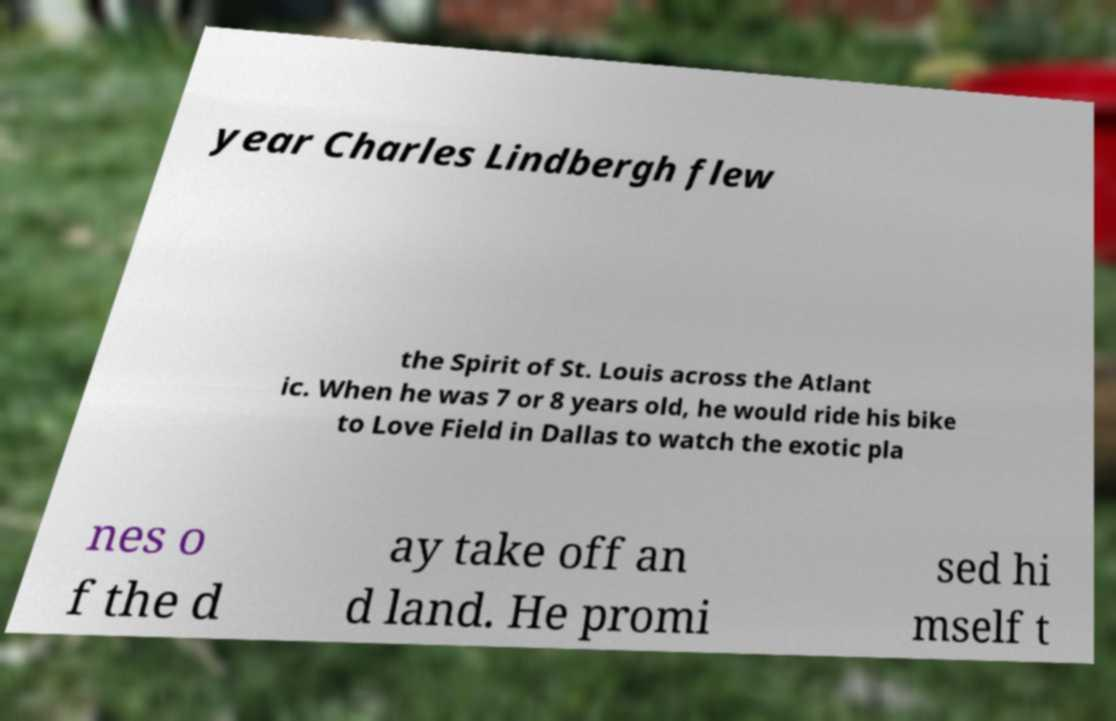What messages or text are displayed in this image? I need them in a readable, typed format. year Charles Lindbergh flew the Spirit of St. Louis across the Atlant ic. When he was 7 or 8 years old, he would ride his bike to Love Field in Dallas to watch the exotic pla nes o f the d ay take off an d land. He promi sed hi mself t 